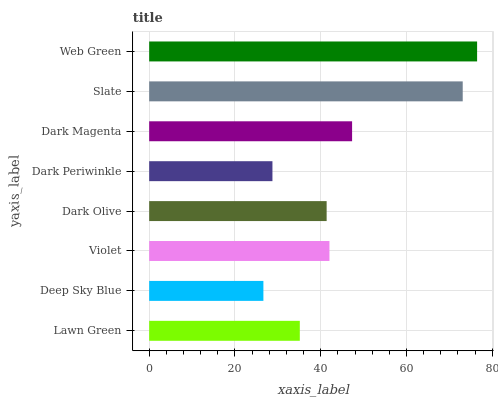Is Deep Sky Blue the minimum?
Answer yes or no. Yes. Is Web Green the maximum?
Answer yes or no. Yes. Is Violet the minimum?
Answer yes or no. No. Is Violet the maximum?
Answer yes or no. No. Is Violet greater than Deep Sky Blue?
Answer yes or no. Yes. Is Deep Sky Blue less than Violet?
Answer yes or no. Yes. Is Deep Sky Blue greater than Violet?
Answer yes or no. No. Is Violet less than Deep Sky Blue?
Answer yes or no. No. Is Violet the high median?
Answer yes or no. Yes. Is Dark Olive the low median?
Answer yes or no. Yes. Is Dark Magenta the high median?
Answer yes or no. No. Is Web Green the low median?
Answer yes or no. No. 